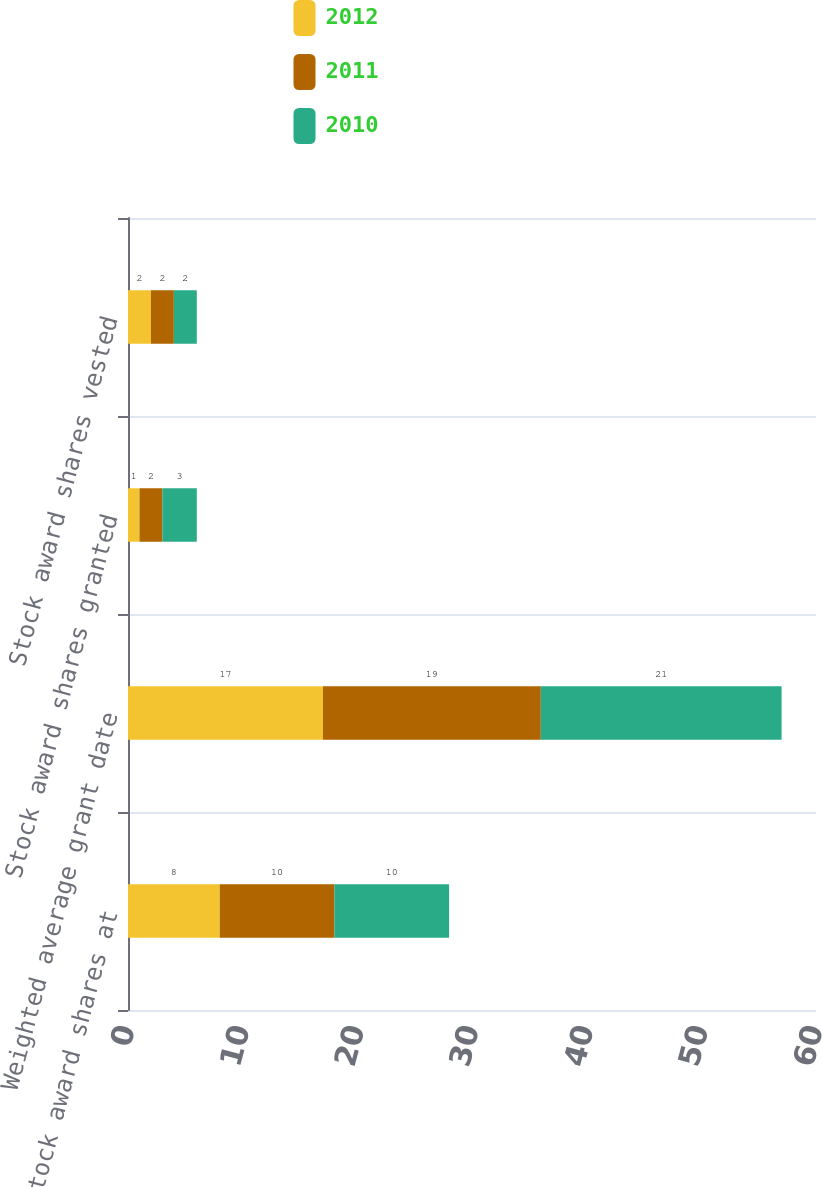Convert chart. <chart><loc_0><loc_0><loc_500><loc_500><stacked_bar_chart><ecel><fcel>Unvested stock award shares at<fcel>Weighted average grant date<fcel>Stock award shares granted<fcel>Stock award shares vested<nl><fcel>2012<fcel>8<fcel>17<fcel>1<fcel>2<nl><fcel>2011<fcel>10<fcel>19<fcel>2<fcel>2<nl><fcel>2010<fcel>10<fcel>21<fcel>3<fcel>2<nl></chart> 